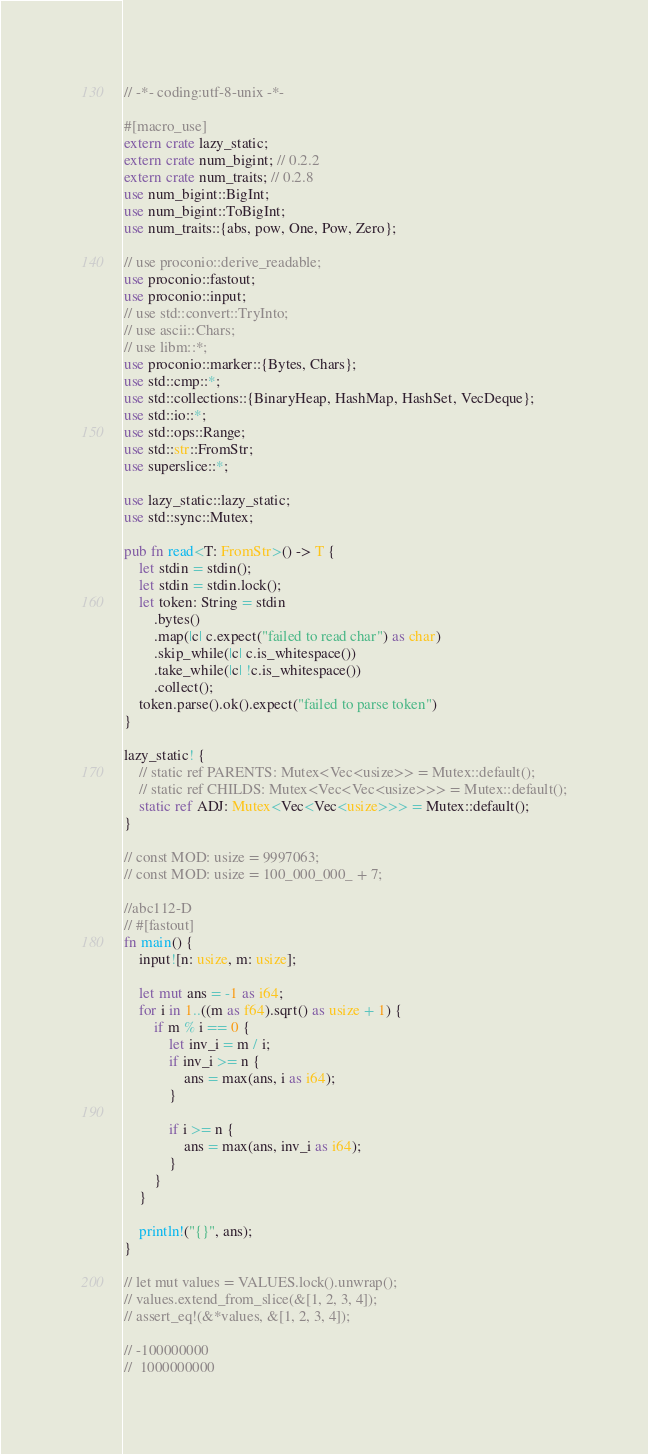<code> <loc_0><loc_0><loc_500><loc_500><_Rust_>// -*- coding:utf-8-unix -*-

#[macro_use]
extern crate lazy_static;
extern crate num_bigint; // 0.2.2
extern crate num_traits; // 0.2.8
use num_bigint::BigInt;
use num_bigint::ToBigInt;
use num_traits::{abs, pow, One, Pow, Zero};

// use proconio::derive_readable;
use proconio::fastout;
use proconio::input;
// use std::convert::TryInto;
// use ascii::Chars;
// use libm::*;
use proconio::marker::{Bytes, Chars};
use std::cmp::*;
use std::collections::{BinaryHeap, HashMap, HashSet, VecDeque};
use std::io::*;
use std::ops::Range;
use std::str::FromStr;
use superslice::*;

use lazy_static::lazy_static;
use std::sync::Mutex;

pub fn read<T: FromStr>() -> T {
    let stdin = stdin();
    let stdin = stdin.lock();
    let token: String = stdin
        .bytes()
        .map(|c| c.expect("failed to read char") as char)
        .skip_while(|c| c.is_whitespace())
        .take_while(|c| !c.is_whitespace())
        .collect();
    token.parse().ok().expect("failed to parse token")
}

lazy_static! {
    // static ref PARENTS: Mutex<Vec<usize>> = Mutex::default();
    // static ref CHILDS: Mutex<Vec<Vec<usize>>> = Mutex::default();
    static ref ADJ: Mutex<Vec<Vec<usize>>> = Mutex::default();
}

// const MOD: usize = 9997063;
// const MOD: usize = 100_000_000_ + 7;

//abc112-D
// #[fastout]
fn main() {
    input![n: usize, m: usize];

    let mut ans = -1 as i64;
    for i in 1..((m as f64).sqrt() as usize + 1) {
        if m % i == 0 {
            let inv_i = m / i;
            if inv_i >= n {
                ans = max(ans, i as i64);
            }

            if i >= n {
                ans = max(ans, inv_i as i64);
            }
        }
    }

    println!("{}", ans);
}

// let mut values = VALUES.lock().unwrap();
// values.extend_from_slice(&[1, 2, 3, 4]);
// assert_eq!(&*values, &[1, 2, 3, 4]);

// -100000000
//  1000000000
</code> 